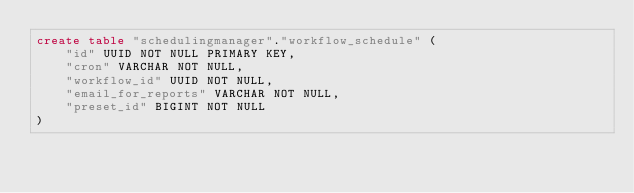Convert code to text. <code><loc_0><loc_0><loc_500><loc_500><_SQL_>create table "schedulingmanager"."workflow_schedule" (
    "id" UUID NOT NULL PRIMARY KEY,
    "cron" VARCHAR NOT NULL,
    "workflow_id" UUID NOT NULL,
    "email_for_reports" VARCHAR NOT NULL,
    "preset_id" BIGINT NOT NULL
)
</code> 